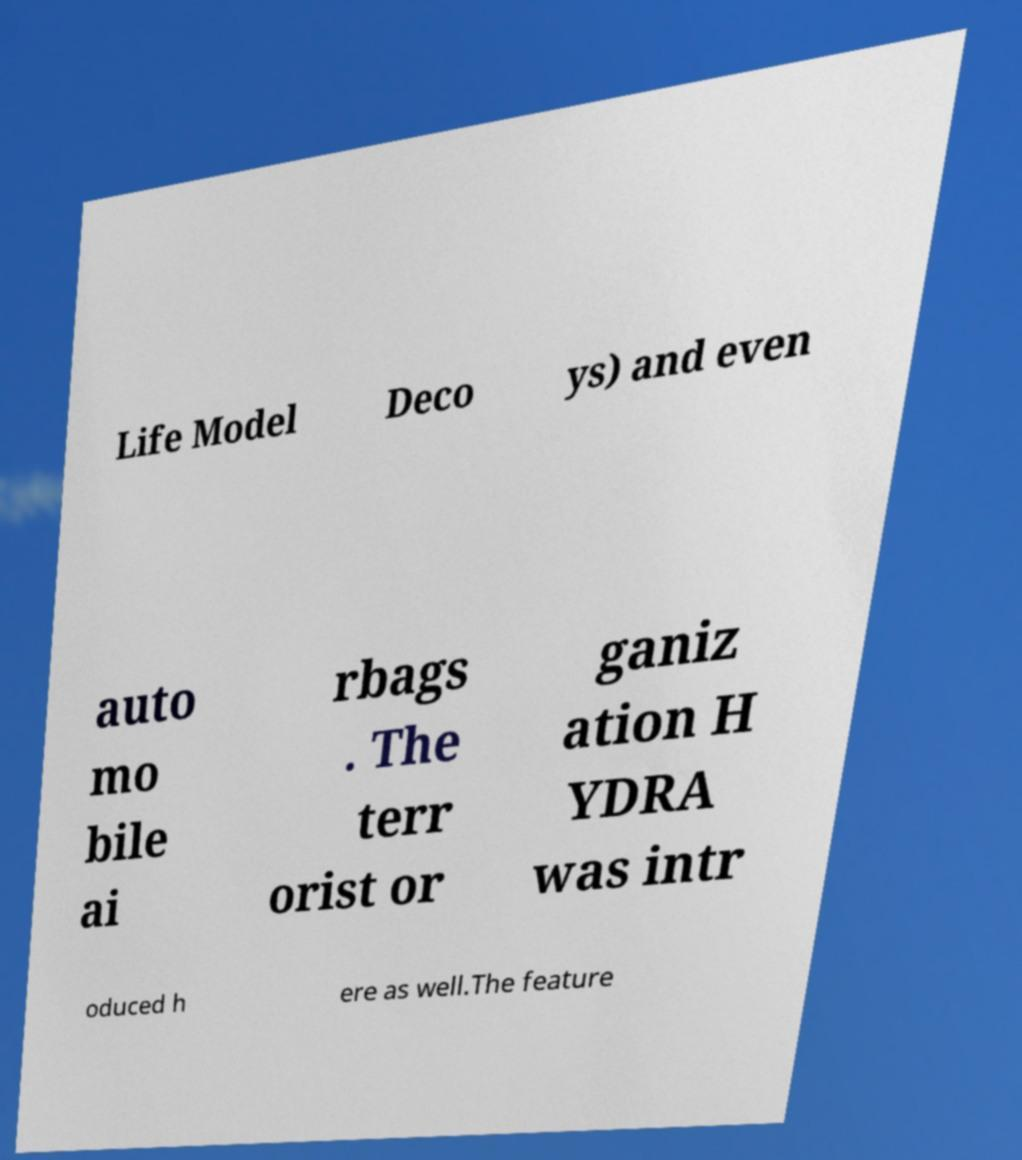Could you extract and type out the text from this image? Life Model Deco ys) and even auto mo bile ai rbags . The terr orist or ganiz ation H YDRA was intr oduced h ere as well.The feature 